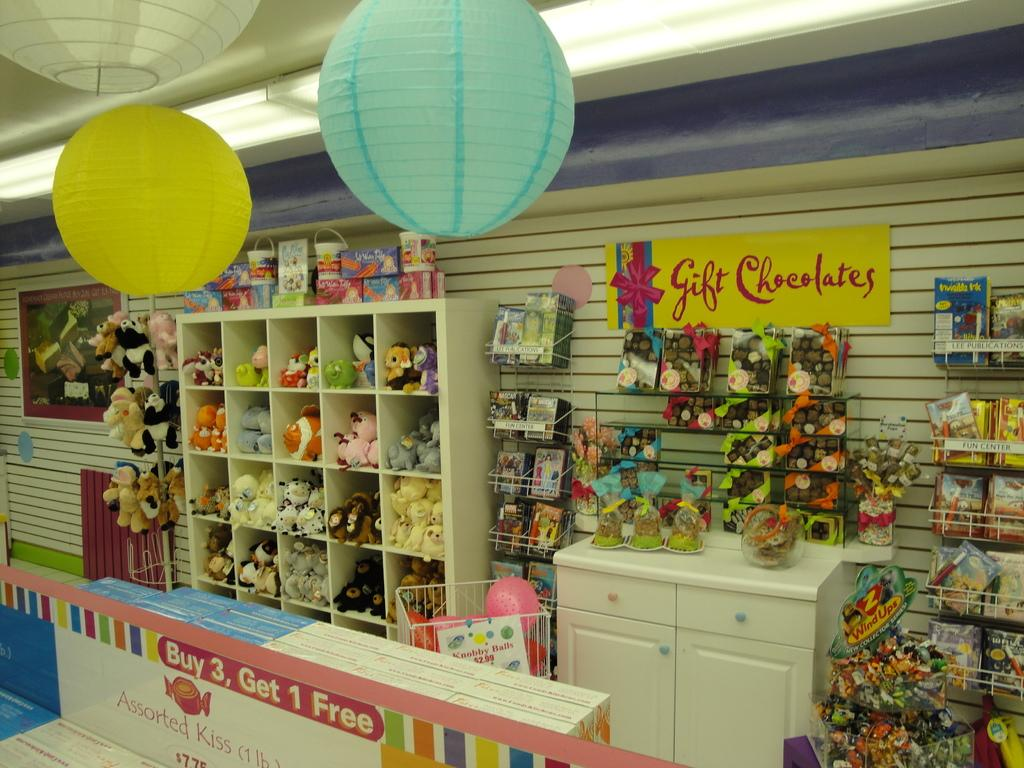Provide a one-sentence caption for the provided image. Th einterior of a gift shop full of stuffed toys, gift chocolates and lanterns. 